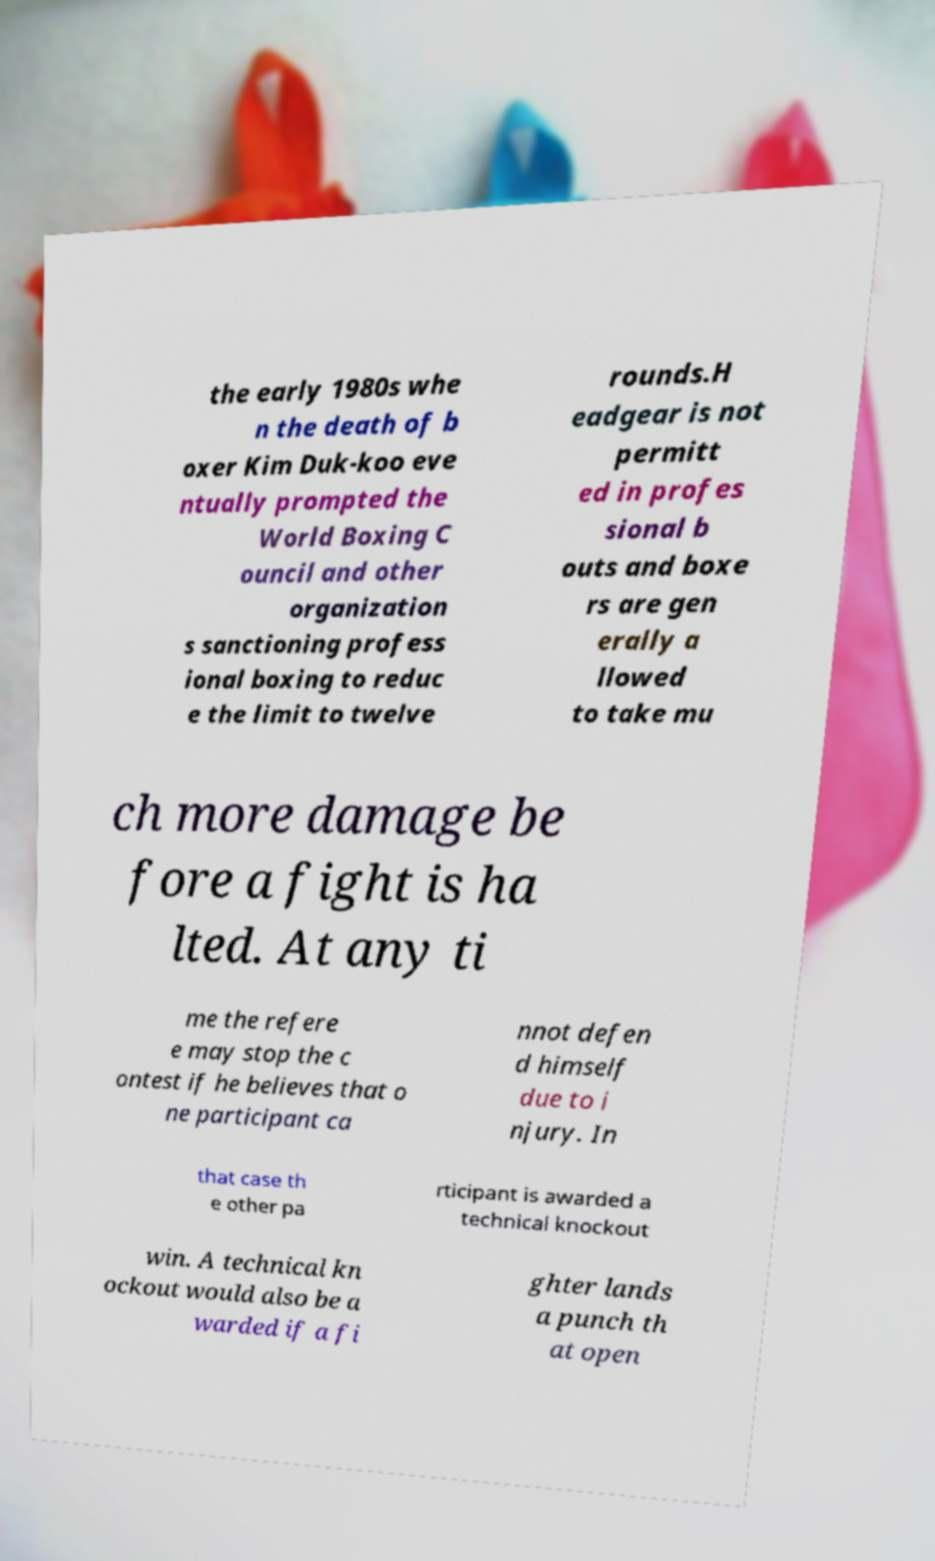Can you accurately transcribe the text from the provided image for me? the early 1980s whe n the death of b oxer Kim Duk-koo eve ntually prompted the World Boxing C ouncil and other organization s sanctioning profess ional boxing to reduc e the limit to twelve rounds.H eadgear is not permitt ed in profes sional b outs and boxe rs are gen erally a llowed to take mu ch more damage be fore a fight is ha lted. At any ti me the refere e may stop the c ontest if he believes that o ne participant ca nnot defen d himself due to i njury. In that case th e other pa rticipant is awarded a technical knockout win. A technical kn ockout would also be a warded if a fi ghter lands a punch th at open 